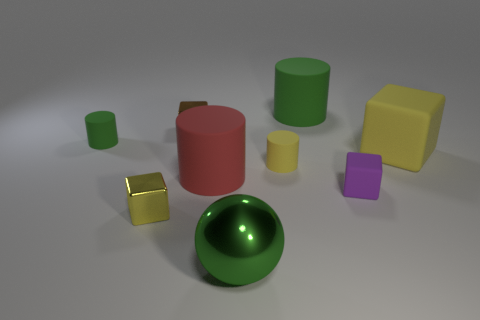Subtract all tiny yellow metal cubes. How many cubes are left? 3 Subtract all blue cylinders. How many yellow cubes are left? 2 Subtract all purple blocks. How many blocks are left? 3 Add 1 big red rubber objects. How many objects exist? 10 Subtract all balls. How many objects are left? 8 Add 7 large red objects. How many large red objects are left? 8 Add 9 large green rubber cylinders. How many large green rubber cylinders exist? 10 Subtract 0 gray spheres. How many objects are left? 9 Subtract all purple balls. Subtract all red cylinders. How many balls are left? 1 Subtract all yellow matte cylinders. Subtract all red matte cylinders. How many objects are left? 7 